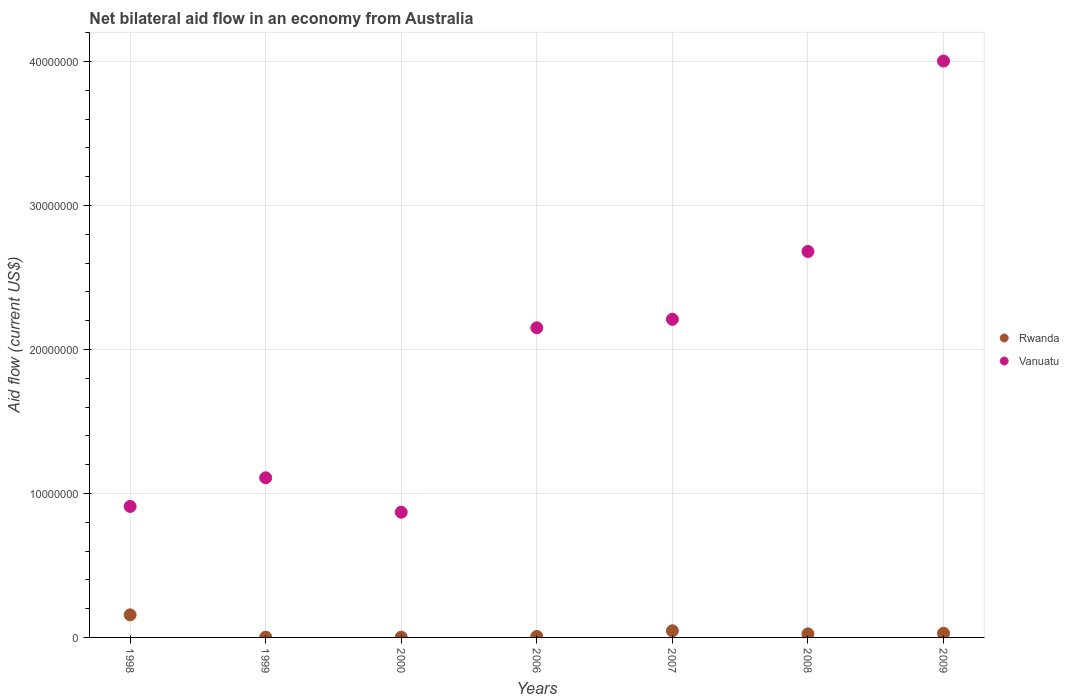Across all years, what is the maximum net bilateral aid flow in Vanuatu?
Make the answer very short. 4.00e+07. Across all years, what is the minimum net bilateral aid flow in Vanuatu?
Your answer should be compact. 8.70e+06. In which year was the net bilateral aid flow in Vanuatu maximum?
Make the answer very short. 2009. In which year was the net bilateral aid flow in Rwanda minimum?
Offer a terse response. 1999. What is the total net bilateral aid flow in Vanuatu in the graph?
Your answer should be compact. 1.39e+08. What is the difference between the net bilateral aid flow in Rwanda in 1998 and that in 1999?
Your answer should be compact. 1.55e+06. What is the difference between the net bilateral aid flow in Rwanda in 2000 and the net bilateral aid flow in Vanuatu in 2008?
Provide a short and direct response. -2.68e+07. What is the average net bilateral aid flow in Rwanda per year?
Provide a short and direct response. 3.83e+05. In the year 2000, what is the difference between the net bilateral aid flow in Vanuatu and net bilateral aid flow in Rwanda?
Your answer should be compact. 8.68e+06. In how many years, is the net bilateral aid flow in Vanuatu greater than 40000000 US$?
Your answer should be very brief. 1. What is the ratio of the net bilateral aid flow in Vanuatu in 1999 to that in 2000?
Offer a very short reply. 1.27. Is the difference between the net bilateral aid flow in Vanuatu in 2000 and 2009 greater than the difference between the net bilateral aid flow in Rwanda in 2000 and 2009?
Make the answer very short. No. What is the difference between the highest and the second highest net bilateral aid flow in Vanuatu?
Your answer should be compact. 1.32e+07. What is the difference between the highest and the lowest net bilateral aid flow in Vanuatu?
Offer a terse response. 3.13e+07. Does the net bilateral aid flow in Vanuatu monotonically increase over the years?
Offer a terse response. No. Is the net bilateral aid flow in Rwanda strictly greater than the net bilateral aid flow in Vanuatu over the years?
Provide a succinct answer. No. How many dotlines are there?
Ensure brevity in your answer.  2. How many years are there in the graph?
Provide a succinct answer. 7. Are the values on the major ticks of Y-axis written in scientific E-notation?
Your answer should be compact. No. Does the graph contain any zero values?
Your response must be concise. No. How many legend labels are there?
Offer a very short reply. 2. What is the title of the graph?
Your response must be concise. Net bilateral aid flow in an economy from Australia. Does "Germany" appear as one of the legend labels in the graph?
Ensure brevity in your answer.  No. What is the label or title of the Y-axis?
Your answer should be very brief. Aid flow (current US$). What is the Aid flow (current US$) in Rwanda in 1998?
Your answer should be compact. 1.57e+06. What is the Aid flow (current US$) of Vanuatu in 1998?
Provide a short and direct response. 9.10e+06. What is the Aid flow (current US$) in Rwanda in 1999?
Make the answer very short. 2.00e+04. What is the Aid flow (current US$) in Vanuatu in 1999?
Keep it short and to the point. 1.11e+07. What is the Aid flow (current US$) in Vanuatu in 2000?
Give a very brief answer. 8.70e+06. What is the Aid flow (current US$) of Vanuatu in 2006?
Your answer should be very brief. 2.15e+07. What is the Aid flow (current US$) of Vanuatu in 2007?
Make the answer very short. 2.21e+07. What is the Aid flow (current US$) of Vanuatu in 2008?
Your response must be concise. 2.68e+07. What is the Aid flow (current US$) of Vanuatu in 2009?
Give a very brief answer. 4.00e+07. Across all years, what is the maximum Aid flow (current US$) of Rwanda?
Keep it short and to the point. 1.57e+06. Across all years, what is the maximum Aid flow (current US$) in Vanuatu?
Give a very brief answer. 4.00e+07. Across all years, what is the minimum Aid flow (current US$) of Vanuatu?
Give a very brief answer. 8.70e+06. What is the total Aid flow (current US$) of Rwanda in the graph?
Provide a succinct answer. 2.68e+06. What is the total Aid flow (current US$) of Vanuatu in the graph?
Ensure brevity in your answer.  1.39e+08. What is the difference between the Aid flow (current US$) in Rwanda in 1998 and that in 1999?
Offer a very short reply. 1.55e+06. What is the difference between the Aid flow (current US$) in Vanuatu in 1998 and that in 1999?
Keep it short and to the point. -1.99e+06. What is the difference between the Aid flow (current US$) of Rwanda in 1998 and that in 2000?
Offer a very short reply. 1.55e+06. What is the difference between the Aid flow (current US$) in Rwanda in 1998 and that in 2006?
Ensure brevity in your answer.  1.50e+06. What is the difference between the Aid flow (current US$) of Vanuatu in 1998 and that in 2006?
Your answer should be very brief. -1.24e+07. What is the difference between the Aid flow (current US$) in Rwanda in 1998 and that in 2007?
Offer a very short reply. 1.11e+06. What is the difference between the Aid flow (current US$) of Vanuatu in 1998 and that in 2007?
Provide a short and direct response. -1.30e+07. What is the difference between the Aid flow (current US$) in Rwanda in 1998 and that in 2008?
Ensure brevity in your answer.  1.32e+06. What is the difference between the Aid flow (current US$) in Vanuatu in 1998 and that in 2008?
Your response must be concise. -1.77e+07. What is the difference between the Aid flow (current US$) in Rwanda in 1998 and that in 2009?
Offer a very short reply. 1.28e+06. What is the difference between the Aid flow (current US$) of Vanuatu in 1998 and that in 2009?
Ensure brevity in your answer.  -3.09e+07. What is the difference between the Aid flow (current US$) of Vanuatu in 1999 and that in 2000?
Your response must be concise. 2.39e+06. What is the difference between the Aid flow (current US$) of Rwanda in 1999 and that in 2006?
Your response must be concise. -5.00e+04. What is the difference between the Aid flow (current US$) of Vanuatu in 1999 and that in 2006?
Offer a terse response. -1.04e+07. What is the difference between the Aid flow (current US$) of Rwanda in 1999 and that in 2007?
Ensure brevity in your answer.  -4.40e+05. What is the difference between the Aid flow (current US$) in Vanuatu in 1999 and that in 2007?
Offer a terse response. -1.10e+07. What is the difference between the Aid flow (current US$) in Rwanda in 1999 and that in 2008?
Offer a terse response. -2.30e+05. What is the difference between the Aid flow (current US$) in Vanuatu in 1999 and that in 2008?
Give a very brief answer. -1.57e+07. What is the difference between the Aid flow (current US$) of Rwanda in 1999 and that in 2009?
Your answer should be very brief. -2.70e+05. What is the difference between the Aid flow (current US$) in Vanuatu in 1999 and that in 2009?
Your answer should be very brief. -2.90e+07. What is the difference between the Aid flow (current US$) of Rwanda in 2000 and that in 2006?
Provide a short and direct response. -5.00e+04. What is the difference between the Aid flow (current US$) in Vanuatu in 2000 and that in 2006?
Your answer should be very brief. -1.28e+07. What is the difference between the Aid flow (current US$) in Rwanda in 2000 and that in 2007?
Give a very brief answer. -4.40e+05. What is the difference between the Aid flow (current US$) in Vanuatu in 2000 and that in 2007?
Offer a terse response. -1.34e+07. What is the difference between the Aid flow (current US$) of Vanuatu in 2000 and that in 2008?
Offer a very short reply. -1.81e+07. What is the difference between the Aid flow (current US$) in Rwanda in 2000 and that in 2009?
Offer a very short reply. -2.70e+05. What is the difference between the Aid flow (current US$) of Vanuatu in 2000 and that in 2009?
Provide a short and direct response. -3.13e+07. What is the difference between the Aid flow (current US$) in Rwanda in 2006 and that in 2007?
Your response must be concise. -3.90e+05. What is the difference between the Aid flow (current US$) of Vanuatu in 2006 and that in 2007?
Your answer should be compact. -5.90e+05. What is the difference between the Aid flow (current US$) in Rwanda in 2006 and that in 2008?
Make the answer very short. -1.80e+05. What is the difference between the Aid flow (current US$) of Vanuatu in 2006 and that in 2008?
Ensure brevity in your answer.  -5.30e+06. What is the difference between the Aid flow (current US$) in Rwanda in 2006 and that in 2009?
Your answer should be very brief. -2.20e+05. What is the difference between the Aid flow (current US$) of Vanuatu in 2006 and that in 2009?
Keep it short and to the point. -1.85e+07. What is the difference between the Aid flow (current US$) of Rwanda in 2007 and that in 2008?
Make the answer very short. 2.10e+05. What is the difference between the Aid flow (current US$) of Vanuatu in 2007 and that in 2008?
Give a very brief answer. -4.71e+06. What is the difference between the Aid flow (current US$) of Rwanda in 2007 and that in 2009?
Provide a short and direct response. 1.70e+05. What is the difference between the Aid flow (current US$) of Vanuatu in 2007 and that in 2009?
Provide a short and direct response. -1.79e+07. What is the difference between the Aid flow (current US$) in Rwanda in 2008 and that in 2009?
Make the answer very short. -4.00e+04. What is the difference between the Aid flow (current US$) in Vanuatu in 2008 and that in 2009?
Ensure brevity in your answer.  -1.32e+07. What is the difference between the Aid flow (current US$) in Rwanda in 1998 and the Aid flow (current US$) in Vanuatu in 1999?
Provide a succinct answer. -9.52e+06. What is the difference between the Aid flow (current US$) of Rwanda in 1998 and the Aid flow (current US$) of Vanuatu in 2000?
Offer a very short reply. -7.13e+06. What is the difference between the Aid flow (current US$) in Rwanda in 1998 and the Aid flow (current US$) in Vanuatu in 2006?
Offer a very short reply. -1.99e+07. What is the difference between the Aid flow (current US$) of Rwanda in 1998 and the Aid flow (current US$) of Vanuatu in 2007?
Your response must be concise. -2.05e+07. What is the difference between the Aid flow (current US$) of Rwanda in 1998 and the Aid flow (current US$) of Vanuatu in 2008?
Your answer should be very brief. -2.52e+07. What is the difference between the Aid flow (current US$) in Rwanda in 1998 and the Aid flow (current US$) in Vanuatu in 2009?
Your answer should be compact. -3.85e+07. What is the difference between the Aid flow (current US$) of Rwanda in 1999 and the Aid flow (current US$) of Vanuatu in 2000?
Keep it short and to the point. -8.68e+06. What is the difference between the Aid flow (current US$) in Rwanda in 1999 and the Aid flow (current US$) in Vanuatu in 2006?
Your answer should be compact. -2.15e+07. What is the difference between the Aid flow (current US$) of Rwanda in 1999 and the Aid flow (current US$) of Vanuatu in 2007?
Your answer should be very brief. -2.21e+07. What is the difference between the Aid flow (current US$) in Rwanda in 1999 and the Aid flow (current US$) in Vanuatu in 2008?
Provide a succinct answer. -2.68e+07. What is the difference between the Aid flow (current US$) of Rwanda in 1999 and the Aid flow (current US$) of Vanuatu in 2009?
Offer a terse response. -4.00e+07. What is the difference between the Aid flow (current US$) in Rwanda in 2000 and the Aid flow (current US$) in Vanuatu in 2006?
Your answer should be very brief. -2.15e+07. What is the difference between the Aid flow (current US$) of Rwanda in 2000 and the Aid flow (current US$) of Vanuatu in 2007?
Give a very brief answer. -2.21e+07. What is the difference between the Aid flow (current US$) in Rwanda in 2000 and the Aid flow (current US$) in Vanuatu in 2008?
Your answer should be very brief. -2.68e+07. What is the difference between the Aid flow (current US$) of Rwanda in 2000 and the Aid flow (current US$) of Vanuatu in 2009?
Offer a terse response. -4.00e+07. What is the difference between the Aid flow (current US$) in Rwanda in 2006 and the Aid flow (current US$) in Vanuatu in 2007?
Provide a succinct answer. -2.20e+07. What is the difference between the Aid flow (current US$) in Rwanda in 2006 and the Aid flow (current US$) in Vanuatu in 2008?
Offer a terse response. -2.67e+07. What is the difference between the Aid flow (current US$) of Rwanda in 2006 and the Aid flow (current US$) of Vanuatu in 2009?
Offer a very short reply. -4.00e+07. What is the difference between the Aid flow (current US$) of Rwanda in 2007 and the Aid flow (current US$) of Vanuatu in 2008?
Give a very brief answer. -2.64e+07. What is the difference between the Aid flow (current US$) in Rwanda in 2007 and the Aid flow (current US$) in Vanuatu in 2009?
Ensure brevity in your answer.  -3.96e+07. What is the difference between the Aid flow (current US$) in Rwanda in 2008 and the Aid flow (current US$) in Vanuatu in 2009?
Your answer should be compact. -3.98e+07. What is the average Aid flow (current US$) of Rwanda per year?
Your answer should be very brief. 3.83e+05. What is the average Aid flow (current US$) in Vanuatu per year?
Ensure brevity in your answer.  1.99e+07. In the year 1998, what is the difference between the Aid flow (current US$) of Rwanda and Aid flow (current US$) of Vanuatu?
Offer a very short reply. -7.53e+06. In the year 1999, what is the difference between the Aid flow (current US$) in Rwanda and Aid flow (current US$) in Vanuatu?
Your answer should be compact. -1.11e+07. In the year 2000, what is the difference between the Aid flow (current US$) of Rwanda and Aid flow (current US$) of Vanuatu?
Provide a short and direct response. -8.68e+06. In the year 2006, what is the difference between the Aid flow (current US$) of Rwanda and Aid flow (current US$) of Vanuatu?
Your response must be concise. -2.14e+07. In the year 2007, what is the difference between the Aid flow (current US$) in Rwanda and Aid flow (current US$) in Vanuatu?
Your answer should be very brief. -2.16e+07. In the year 2008, what is the difference between the Aid flow (current US$) of Rwanda and Aid flow (current US$) of Vanuatu?
Keep it short and to the point. -2.66e+07. In the year 2009, what is the difference between the Aid flow (current US$) in Rwanda and Aid flow (current US$) in Vanuatu?
Provide a short and direct response. -3.98e+07. What is the ratio of the Aid flow (current US$) of Rwanda in 1998 to that in 1999?
Provide a short and direct response. 78.5. What is the ratio of the Aid flow (current US$) in Vanuatu in 1998 to that in 1999?
Your answer should be very brief. 0.82. What is the ratio of the Aid flow (current US$) in Rwanda in 1998 to that in 2000?
Your answer should be very brief. 78.5. What is the ratio of the Aid flow (current US$) in Vanuatu in 1998 to that in 2000?
Offer a very short reply. 1.05. What is the ratio of the Aid flow (current US$) of Rwanda in 1998 to that in 2006?
Your answer should be very brief. 22.43. What is the ratio of the Aid flow (current US$) of Vanuatu in 1998 to that in 2006?
Provide a succinct answer. 0.42. What is the ratio of the Aid flow (current US$) of Rwanda in 1998 to that in 2007?
Your answer should be very brief. 3.41. What is the ratio of the Aid flow (current US$) in Vanuatu in 1998 to that in 2007?
Make the answer very short. 0.41. What is the ratio of the Aid flow (current US$) of Rwanda in 1998 to that in 2008?
Offer a terse response. 6.28. What is the ratio of the Aid flow (current US$) of Vanuatu in 1998 to that in 2008?
Make the answer very short. 0.34. What is the ratio of the Aid flow (current US$) of Rwanda in 1998 to that in 2009?
Provide a short and direct response. 5.41. What is the ratio of the Aid flow (current US$) of Vanuatu in 1998 to that in 2009?
Make the answer very short. 0.23. What is the ratio of the Aid flow (current US$) of Vanuatu in 1999 to that in 2000?
Offer a terse response. 1.27. What is the ratio of the Aid flow (current US$) of Rwanda in 1999 to that in 2006?
Provide a short and direct response. 0.29. What is the ratio of the Aid flow (current US$) of Vanuatu in 1999 to that in 2006?
Provide a short and direct response. 0.52. What is the ratio of the Aid flow (current US$) of Rwanda in 1999 to that in 2007?
Provide a short and direct response. 0.04. What is the ratio of the Aid flow (current US$) of Vanuatu in 1999 to that in 2007?
Provide a succinct answer. 0.5. What is the ratio of the Aid flow (current US$) in Vanuatu in 1999 to that in 2008?
Offer a terse response. 0.41. What is the ratio of the Aid flow (current US$) of Rwanda in 1999 to that in 2009?
Your answer should be very brief. 0.07. What is the ratio of the Aid flow (current US$) of Vanuatu in 1999 to that in 2009?
Your response must be concise. 0.28. What is the ratio of the Aid flow (current US$) of Rwanda in 2000 to that in 2006?
Your response must be concise. 0.29. What is the ratio of the Aid flow (current US$) in Vanuatu in 2000 to that in 2006?
Offer a very short reply. 0.4. What is the ratio of the Aid flow (current US$) of Rwanda in 2000 to that in 2007?
Offer a terse response. 0.04. What is the ratio of the Aid flow (current US$) in Vanuatu in 2000 to that in 2007?
Give a very brief answer. 0.39. What is the ratio of the Aid flow (current US$) of Vanuatu in 2000 to that in 2008?
Give a very brief answer. 0.32. What is the ratio of the Aid flow (current US$) of Rwanda in 2000 to that in 2009?
Your answer should be very brief. 0.07. What is the ratio of the Aid flow (current US$) in Vanuatu in 2000 to that in 2009?
Provide a succinct answer. 0.22. What is the ratio of the Aid flow (current US$) of Rwanda in 2006 to that in 2007?
Provide a succinct answer. 0.15. What is the ratio of the Aid flow (current US$) in Vanuatu in 2006 to that in 2007?
Ensure brevity in your answer.  0.97. What is the ratio of the Aid flow (current US$) of Rwanda in 2006 to that in 2008?
Give a very brief answer. 0.28. What is the ratio of the Aid flow (current US$) of Vanuatu in 2006 to that in 2008?
Provide a short and direct response. 0.8. What is the ratio of the Aid flow (current US$) of Rwanda in 2006 to that in 2009?
Give a very brief answer. 0.24. What is the ratio of the Aid flow (current US$) in Vanuatu in 2006 to that in 2009?
Your answer should be very brief. 0.54. What is the ratio of the Aid flow (current US$) in Rwanda in 2007 to that in 2008?
Provide a succinct answer. 1.84. What is the ratio of the Aid flow (current US$) of Vanuatu in 2007 to that in 2008?
Make the answer very short. 0.82. What is the ratio of the Aid flow (current US$) of Rwanda in 2007 to that in 2009?
Offer a very short reply. 1.59. What is the ratio of the Aid flow (current US$) of Vanuatu in 2007 to that in 2009?
Make the answer very short. 0.55. What is the ratio of the Aid flow (current US$) in Rwanda in 2008 to that in 2009?
Offer a very short reply. 0.86. What is the ratio of the Aid flow (current US$) of Vanuatu in 2008 to that in 2009?
Give a very brief answer. 0.67. What is the difference between the highest and the second highest Aid flow (current US$) in Rwanda?
Offer a terse response. 1.11e+06. What is the difference between the highest and the second highest Aid flow (current US$) of Vanuatu?
Offer a terse response. 1.32e+07. What is the difference between the highest and the lowest Aid flow (current US$) in Rwanda?
Your response must be concise. 1.55e+06. What is the difference between the highest and the lowest Aid flow (current US$) in Vanuatu?
Offer a very short reply. 3.13e+07. 